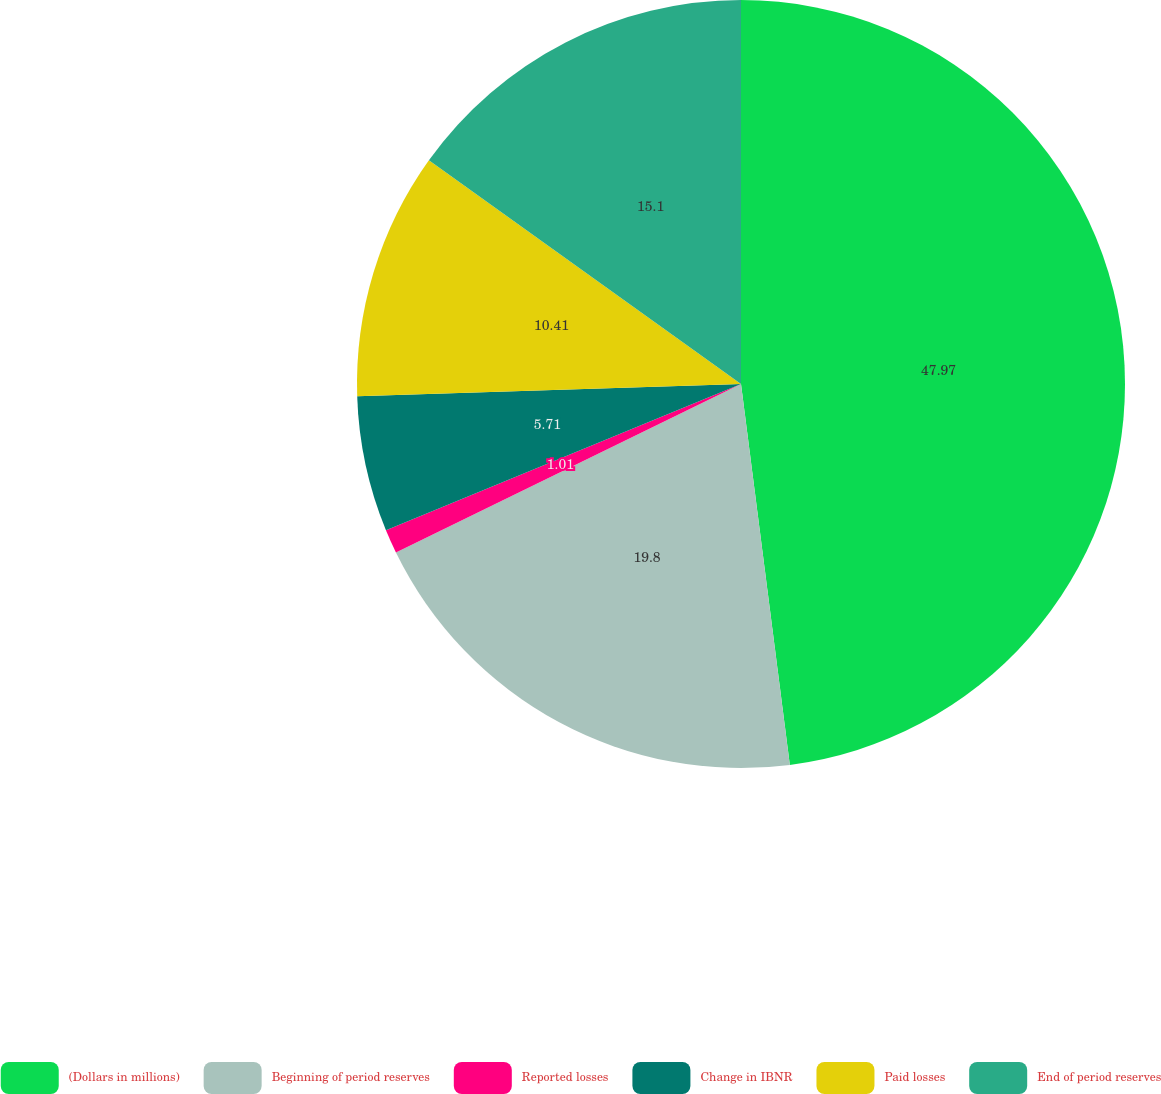Convert chart to OTSL. <chart><loc_0><loc_0><loc_500><loc_500><pie_chart><fcel>(Dollars in millions)<fcel>Beginning of period reserves<fcel>Reported losses<fcel>Change in IBNR<fcel>Paid losses<fcel>End of period reserves<nl><fcel>47.97%<fcel>19.8%<fcel>1.01%<fcel>5.71%<fcel>10.41%<fcel>15.1%<nl></chart> 